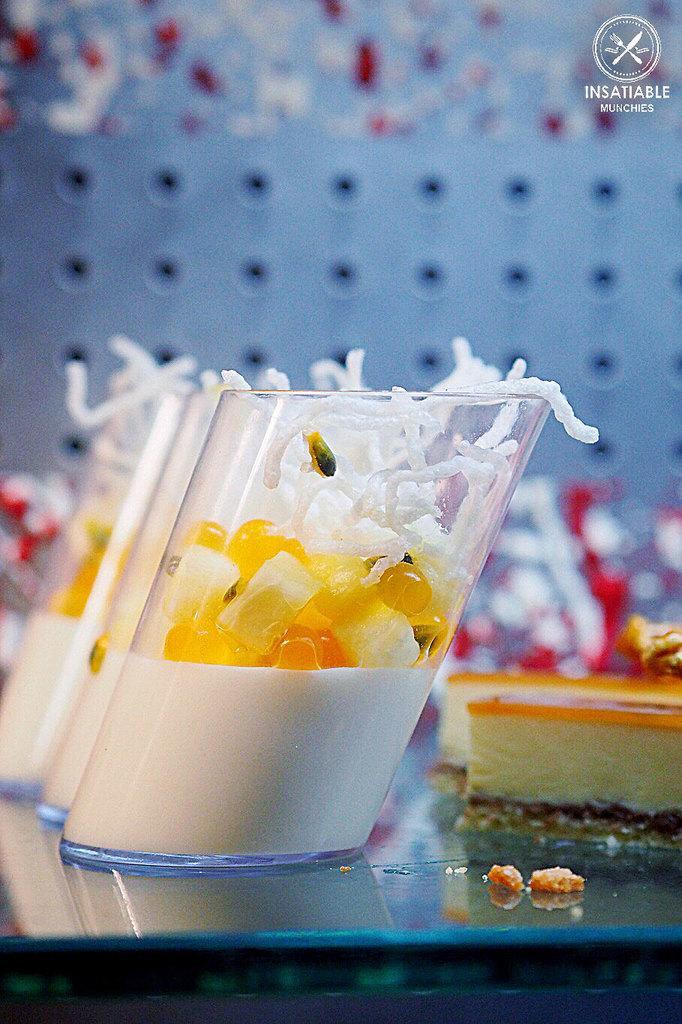Could you give a brief overview of what you see in this image? There is a platform. On that there are food items and glass vessels with food items. In the right top corner there is a watermark. 